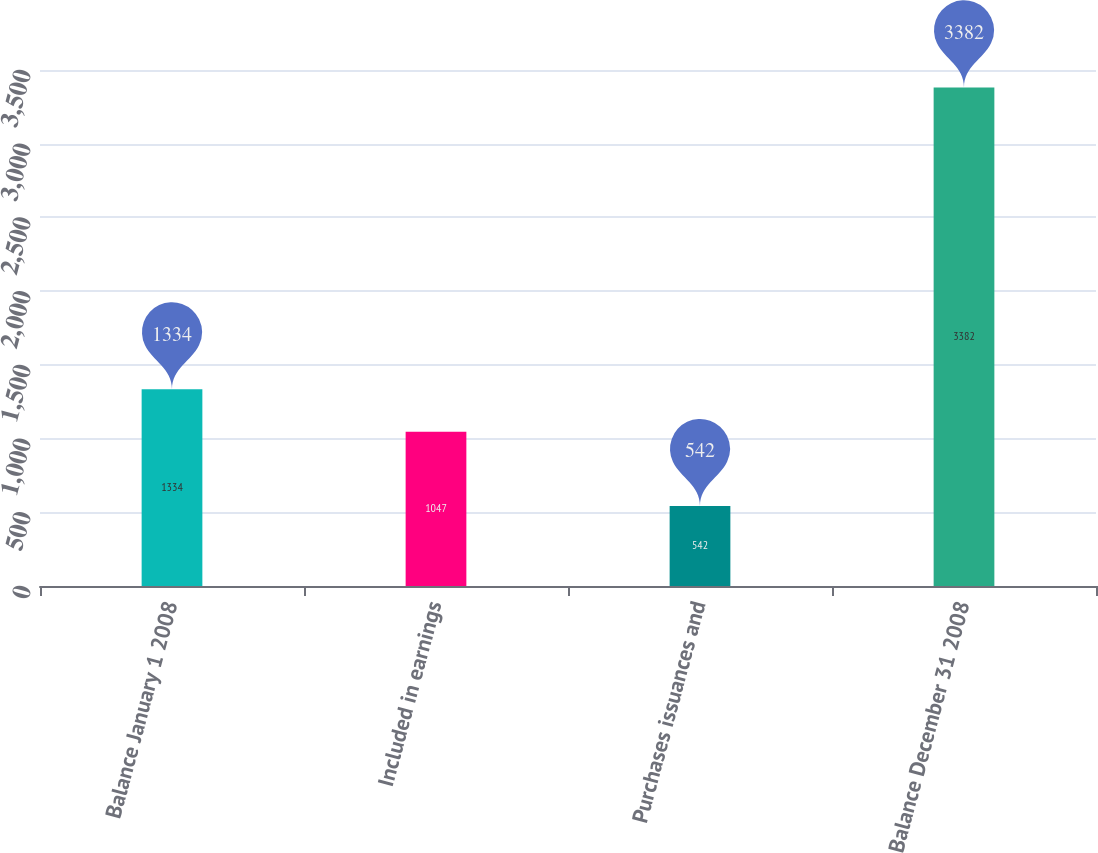<chart> <loc_0><loc_0><loc_500><loc_500><bar_chart><fcel>Balance January 1 2008<fcel>Included in earnings<fcel>Purchases issuances and<fcel>Balance December 31 2008<nl><fcel>1334<fcel>1047<fcel>542<fcel>3382<nl></chart> 